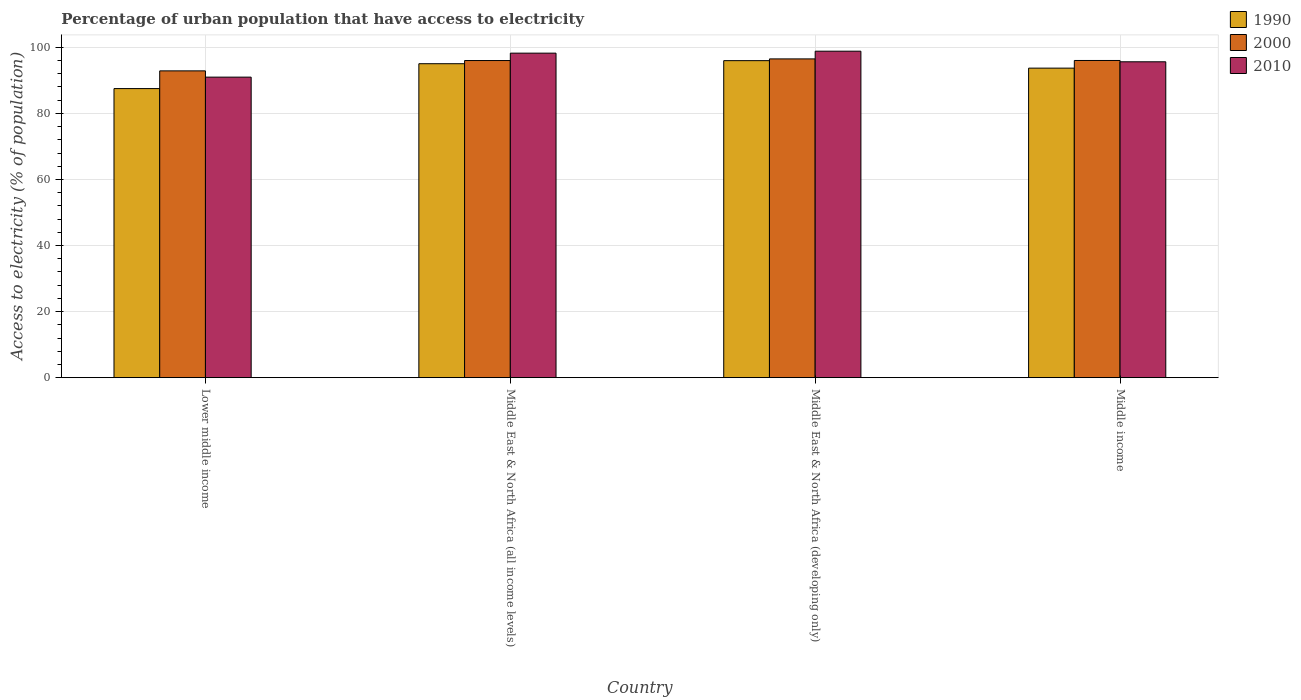How many different coloured bars are there?
Your response must be concise. 3. How many groups of bars are there?
Provide a short and direct response. 4. How many bars are there on the 1st tick from the right?
Provide a succinct answer. 3. What is the label of the 2nd group of bars from the left?
Offer a very short reply. Middle East & North Africa (all income levels). What is the percentage of urban population that have access to electricity in 2010 in Lower middle income?
Make the answer very short. 90.97. Across all countries, what is the maximum percentage of urban population that have access to electricity in 2000?
Make the answer very short. 96.48. Across all countries, what is the minimum percentage of urban population that have access to electricity in 1990?
Provide a succinct answer. 87.5. In which country was the percentage of urban population that have access to electricity in 2000 maximum?
Your response must be concise. Middle East & North Africa (developing only). In which country was the percentage of urban population that have access to electricity in 2000 minimum?
Offer a very short reply. Lower middle income. What is the total percentage of urban population that have access to electricity in 1990 in the graph?
Offer a terse response. 372.17. What is the difference between the percentage of urban population that have access to electricity in 2010 in Middle East & North Africa (all income levels) and that in Middle income?
Give a very brief answer. 2.62. What is the difference between the percentage of urban population that have access to electricity in 2000 in Middle East & North Africa (developing only) and the percentage of urban population that have access to electricity in 2010 in Middle East & North Africa (all income levels)?
Provide a succinct answer. -1.74. What is the average percentage of urban population that have access to electricity in 2000 per country?
Provide a succinct answer. 95.34. What is the difference between the percentage of urban population that have access to electricity of/in 2010 and percentage of urban population that have access to electricity of/in 2000 in Middle East & North Africa (developing only)?
Your answer should be very brief. 2.33. In how many countries, is the percentage of urban population that have access to electricity in 1990 greater than 80 %?
Give a very brief answer. 4. What is the ratio of the percentage of urban population that have access to electricity in 2000 in Middle East & North Africa (developing only) to that in Middle income?
Provide a succinct answer. 1. What is the difference between the highest and the second highest percentage of urban population that have access to electricity in 2010?
Your answer should be very brief. 0.59. What is the difference between the highest and the lowest percentage of urban population that have access to electricity in 2000?
Your answer should be very brief. 3.62. In how many countries, is the percentage of urban population that have access to electricity in 2010 greater than the average percentage of urban population that have access to electricity in 2010 taken over all countries?
Keep it short and to the point. 2. What does the 3rd bar from the left in Middle income represents?
Your response must be concise. 2010. What does the 1st bar from the right in Middle income represents?
Give a very brief answer. 2010. Are all the bars in the graph horizontal?
Make the answer very short. No. What is the difference between two consecutive major ticks on the Y-axis?
Offer a terse response. 20. Does the graph contain any zero values?
Ensure brevity in your answer.  No. Where does the legend appear in the graph?
Your response must be concise. Top right. How are the legend labels stacked?
Ensure brevity in your answer.  Vertical. What is the title of the graph?
Keep it short and to the point. Percentage of urban population that have access to electricity. What is the label or title of the Y-axis?
Keep it short and to the point. Access to electricity (% of population). What is the Access to electricity (% of population) of 1990 in Lower middle income?
Provide a succinct answer. 87.5. What is the Access to electricity (% of population) of 2000 in Lower middle income?
Your response must be concise. 92.86. What is the Access to electricity (% of population) of 2010 in Lower middle income?
Your answer should be compact. 90.97. What is the Access to electricity (% of population) of 1990 in Middle East & North Africa (all income levels)?
Your answer should be compact. 95.03. What is the Access to electricity (% of population) of 2000 in Middle East & North Africa (all income levels)?
Keep it short and to the point. 95.99. What is the Access to electricity (% of population) of 2010 in Middle East & North Africa (all income levels)?
Provide a succinct answer. 98.23. What is the Access to electricity (% of population) in 1990 in Middle East & North Africa (developing only)?
Your response must be concise. 95.95. What is the Access to electricity (% of population) in 2000 in Middle East & North Africa (developing only)?
Provide a short and direct response. 96.48. What is the Access to electricity (% of population) of 2010 in Middle East & North Africa (developing only)?
Make the answer very short. 98.82. What is the Access to electricity (% of population) in 1990 in Middle income?
Give a very brief answer. 93.69. What is the Access to electricity (% of population) of 2000 in Middle income?
Give a very brief answer. 96.01. What is the Access to electricity (% of population) of 2010 in Middle income?
Offer a terse response. 95.61. Across all countries, what is the maximum Access to electricity (% of population) in 1990?
Provide a succinct answer. 95.95. Across all countries, what is the maximum Access to electricity (% of population) of 2000?
Offer a very short reply. 96.48. Across all countries, what is the maximum Access to electricity (% of population) of 2010?
Offer a terse response. 98.82. Across all countries, what is the minimum Access to electricity (% of population) in 1990?
Keep it short and to the point. 87.5. Across all countries, what is the minimum Access to electricity (% of population) in 2000?
Give a very brief answer. 92.86. Across all countries, what is the minimum Access to electricity (% of population) in 2010?
Your answer should be compact. 90.97. What is the total Access to electricity (% of population) of 1990 in the graph?
Provide a short and direct response. 372.17. What is the total Access to electricity (% of population) of 2000 in the graph?
Provide a succinct answer. 381.35. What is the total Access to electricity (% of population) in 2010 in the graph?
Make the answer very short. 383.62. What is the difference between the Access to electricity (% of population) in 1990 in Lower middle income and that in Middle East & North Africa (all income levels)?
Give a very brief answer. -7.53. What is the difference between the Access to electricity (% of population) in 2000 in Lower middle income and that in Middle East & North Africa (all income levels)?
Make the answer very short. -3.13. What is the difference between the Access to electricity (% of population) in 2010 in Lower middle income and that in Middle East & North Africa (all income levels)?
Keep it short and to the point. -7.26. What is the difference between the Access to electricity (% of population) of 1990 in Lower middle income and that in Middle East & North Africa (developing only)?
Offer a very short reply. -8.46. What is the difference between the Access to electricity (% of population) of 2000 in Lower middle income and that in Middle East & North Africa (developing only)?
Offer a very short reply. -3.62. What is the difference between the Access to electricity (% of population) in 2010 in Lower middle income and that in Middle East & North Africa (developing only)?
Your answer should be very brief. -7.85. What is the difference between the Access to electricity (% of population) in 1990 in Lower middle income and that in Middle income?
Your response must be concise. -6.19. What is the difference between the Access to electricity (% of population) of 2000 in Lower middle income and that in Middle income?
Provide a short and direct response. -3.15. What is the difference between the Access to electricity (% of population) of 2010 in Lower middle income and that in Middle income?
Ensure brevity in your answer.  -4.64. What is the difference between the Access to electricity (% of population) in 1990 in Middle East & North Africa (all income levels) and that in Middle East & North Africa (developing only)?
Keep it short and to the point. -0.93. What is the difference between the Access to electricity (% of population) in 2000 in Middle East & North Africa (all income levels) and that in Middle East & North Africa (developing only)?
Keep it short and to the point. -0.49. What is the difference between the Access to electricity (% of population) of 2010 in Middle East & North Africa (all income levels) and that in Middle East & North Africa (developing only)?
Keep it short and to the point. -0.59. What is the difference between the Access to electricity (% of population) in 1990 in Middle East & North Africa (all income levels) and that in Middle income?
Your answer should be compact. 1.34. What is the difference between the Access to electricity (% of population) in 2000 in Middle East & North Africa (all income levels) and that in Middle income?
Provide a succinct answer. -0.02. What is the difference between the Access to electricity (% of population) in 2010 in Middle East & North Africa (all income levels) and that in Middle income?
Keep it short and to the point. 2.62. What is the difference between the Access to electricity (% of population) in 1990 in Middle East & North Africa (developing only) and that in Middle income?
Your answer should be very brief. 2.26. What is the difference between the Access to electricity (% of population) of 2000 in Middle East & North Africa (developing only) and that in Middle income?
Provide a succinct answer. 0.47. What is the difference between the Access to electricity (% of population) of 2010 in Middle East & North Africa (developing only) and that in Middle income?
Ensure brevity in your answer.  3.21. What is the difference between the Access to electricity (% of population) of 1990 in Lower middle income and the Access to electricity (% of population) of 2000 in Middle East & North Africa (all income levels)?
Make the answer very short. -8.49. What is the difference between the Access to electricity (% of population) in 1990 in Lower middle income and the Access to electricity (% of population) in 2010 in Middle East & North Africa (all income levels)?
Provide a short and direct response. -10.73. What is the difference between the Access to electricity (% of population) in 2000 in Lower middle income and the Access to electricity (% of population) in 2010 in Middle East & North Africa (all income levels)?
Make the answer very short. -5.37. What is the difference between the Access to electricity (% of population) of 1990 in Lower middle income and the Access to electricity (% of population) of 2000 in Middle East & North Africa (developing only)?
Give a very brief answer. -8.99. What is the difference between the Access to electricity (% of population) in 1990 in Lower middle income and the Access to electricity (% of population) in 2010 in Middle East & North Africa (developing only)?
Keep it short and to the point. -11.32. What is the difference between the Access to electricity (% of population) of 2000 in Lower middle income and the Access to electricity (% of population) of 2010 in Middle East & North Africa (developing only)?
Make the answer very short. -5.96. What is the difference between the Access to electricity (% of population) of 1990 in Lower middle income and the Access to electricity (% of population) of 2000 in Middle income?
Make the answer very short. -8.51. What is the difference between the Access to electricity (% of population) of 1990 in Lower middle income and the Access to electricity (% of population) of 2010 in Middle income?
Offer a terse response. -8.11. What is the difference between the Access to electricity (% of population) of 2000 in Lower middle income and the Access to electricity (% of population) of 2010 in Middle income?
Keep it short and to the point. -2.75. What is the difference between the Access to electricity (% of population) of 1990 in Middle East & North Africa (all income levels) and the Access to electricity (% of population) of 2000 in Middle East & North Africa (developing only)?
Your answer should be compact. -1.46. What is the difference between the Access to electricity (% of population) of 1990 in Middle East & North Africa (all income levels) and the Access to electricity (% of population) of 2010 in Middle East & North Africa (developing only)?
Offer a very short reply. -3.79. What is the difference between the Access to electricity (% of population) in 2000 in Middle East & North Africa (all income levels) and the Access to electricity (% of population) in 2010 in Middle East & North Africa (developing only)?
Make the answer very short. -2.83. What is the difference between the Access to electricity (% of population) in 1990 in Middle East & North Africa (all income levels) and the Access to electricity (% of population) in 2000 in Middle income?
Provide a short and direct response. -0.98. What is the difference between the Access to electricity (% of population) in 1990 in Middle East & North Africa (all income levels) and the Access to electricity (% of population) in 2010 in Middle income?
Your answer should be compact. -0.58. What is the difference between the Access to electricity (% of population) of 2000 in Middle East & North Africa (all income levels) and the Access to electricity (% of population) of 2010 in Middle income?
Give a very brief answer. 0.38. What is the difference between the Access to electricity (% of population) in 1990 in Middle East & North Africa (developing only) and the Access to electricity (% of population) in 2000 in Middle income?
Offer a terse response. -0.06. What is the difference between the Access to electricity (% of population) of 1990 in Middle East & North Africa (developing only) and the Access to electricity (% of population) of 2010 in Middle income?
Your answer should be compact. 0.34. What is the difference between the Access to electricity (% of population) of 2000 in Middle East & North Africa (developing only) and the Access to electricity (% of population) of 2010 in Middle income?
Your response must be concise. 0.87. What is the average Access to electricity (% of population) in 1990 per country?
Ensure brevity in your answer.  93.04. What is the average Access to electricity (% of population) of 2000 per country?
Your answer should be very brief. 95.34. What is the average Access to electricity (% of population) of 2010 per country?
Your answer should be compact. 95.9. What is the difference between the Access to electricity (% of population) in 1990 and Access to electricity (% of population) in 2000 in Lower middle income?
Ensure brevity in your answer.  -5.36. What is the difference between the Access to electricity (% of population) of 1990 and Access to electricity (% of population) of 2010 in Lower middle income?
Your response must be concise. -3.47. What is the difference between the Access to electricity (% of population) in 2000 and Access to electricity (% of population) in 2010 in Lower middle income?
Keep it short and to the point. 1.9. What is the difference between the Access to electricity (% of population) of 1990 and Access to electricity (% of population) of 2000 in Middle East & North Africa (all income levels)?
Keep it short and to the point. -0.96. What is the difference between the Access to electricity (% of population) in 1990 and Access to electricity (% of population) in 2010 in Middle East & North Africa (all income levels)?
Your answer should be compact. -3.2. What is the difference between the Access to electricity (% of population) in 2000 and Access to electricity (% of population) in 2010 in Middle East & North Africa (all income levels)?
Ensure brevity in your answer.  -2.24. What is the difference between the Access to electricity (% of population) in 1990 and Access to electricity (% of population) in 2000 in Middle East & North Africa (developing only)?
Provide a succinct answer. -0.53. What is the difference between the Access to electricity (% of population) in 1990 and Access to electricity (% of population) in 2010 in Middle East & North Africa (developing only)?
Your answer should be compact. -2.86. What is the difference between the Access to electricity (% of population) in 2000 and Access to electricity (% of population) in 2010 in Middle East & North Africa (developing only)?
Provide a short and direct response. -2.33. What is the difference between the Access to electricity (% of population) of 1990 and Access to electricity (% of population) of 2000 in Middle income?
Provide a short and direct response. -2.32. What is the difference between the Access to electricity (% of population) in 1990 and Access to electricity (% of population) in 2010 in Middle income?
Keep it short and to the point. -1.92. What is the difference between the Access to electricity (% of population) of 2000 and Access to electricity (% of population) of 2010 in Middle income?
Your answer should be compact. 0.4. What is the ratio of the Access to electricity (% of population) of 1990 in Lower middle income to that in Middle East & North Africa (all income levels)?
Keep it short and to the point. 0.92. What is the ratio of the Access to electricity (% of population) in 2000 in Lower middle income to that in Middle East & North Africa (all income levels)?
Your answer should be compact. 0.97. What is the ratio of the Access to electricity (% of population) of 2010 in Lower middle income to that in Middle East & North Africa (all income levels)?
Offer a terse response. 0.93. What is the ratio of the Access to electricity (% of population) of 1990 in Lower middle income to that in Middle East & North Africa (developing only)?
Offer a very short reply. 0.91. What is the ratio of the Access to electricity (% of population) in 2000 in Lower middle income to that in Middle East & North Africa (developing only)?
Provide a succinct answer. 0.96. What is the ratio of the Access to electricity (% of population) of 2010 in Lower middle income to that in Middle East & North Africa (developing only)?
Your answer should be compact. 0.92. What is the ratio of the Access to electricity (% of population) of 1990 in Lower middle income to that in Middle income?
Provide a succinct answer. 0.93. What is the ratio of the Access to electricity (% of population) of 2000 in Lower middle income to that in Middle income?
Make the answer very short. 0.97. What is the ratio of the Access to electricity (% of population) of 2010 in Lower middle income to that in Middle income?
Ensure brevity in your answer.  0.95. What is the ratio of the Access to electricity (% of population) in 1990 in Middle East & North Africa (all income levels) to that in Middle East & North Africa (developing only)?
Give a very brief answer. 0.99. What is the ratio of the Access to electricity (% of population) of 2010 in Middle East & North Africa (all income levels) to that in Middle East & North Africa (developing only)?
Provide a succinct answer. 0.99. What is the ratio of the Access to electricity (% of population) of 1990 in Middle East & North Africa (all income levels) to that in Middle income?
Your answer should be compact. 1.01. What is the ratio of the Access to electricity (% of population) in 2010 in Middle East & North Africa (all income levels) to that in Middle income?
Offer a very short reply. 1.03. What is the ratio of the Access to electricity (% of population) of 1990 in Middle East & North Africa (developing only) to that in Middle income?
Make the answer very short. 1.02. What is the ratio of the Access to electricity (% of population) in 2000 in Middle East & North Africa (developing only) to that in Middle income?
Offer a very short reply. 1. What is the ratio of the Access to electricity (% of population) in 2010 in Middle East & North Africa (developing only) to that in Middle income?
Keep it short and to the point. 1.03. What is the difference between the highest and the second highest Access to electricity (% of population) of 1990?
Make the answer very short. 0.93. What is the difference between the highest and the second highest Access to electricity (% of population) of 2000?
Make the answer very short. 0.47. What is the difference between the highest and the second highest Access to electricity (% of population) in 2010?
Offer a terse response. 0.59. What is the difference between the highest and the lowest Access to electricity (% of population) of 1990?
Your answer should be compact. 8.46. What is the difference between the highest and the lowest Access to electricity (% of population) of 2000?
Keep it short and to the point. 3.62. What is the difference between the highest and the lowest Access to electricity (% of population) of 2010?
Give a very brief answer. 7.85. 